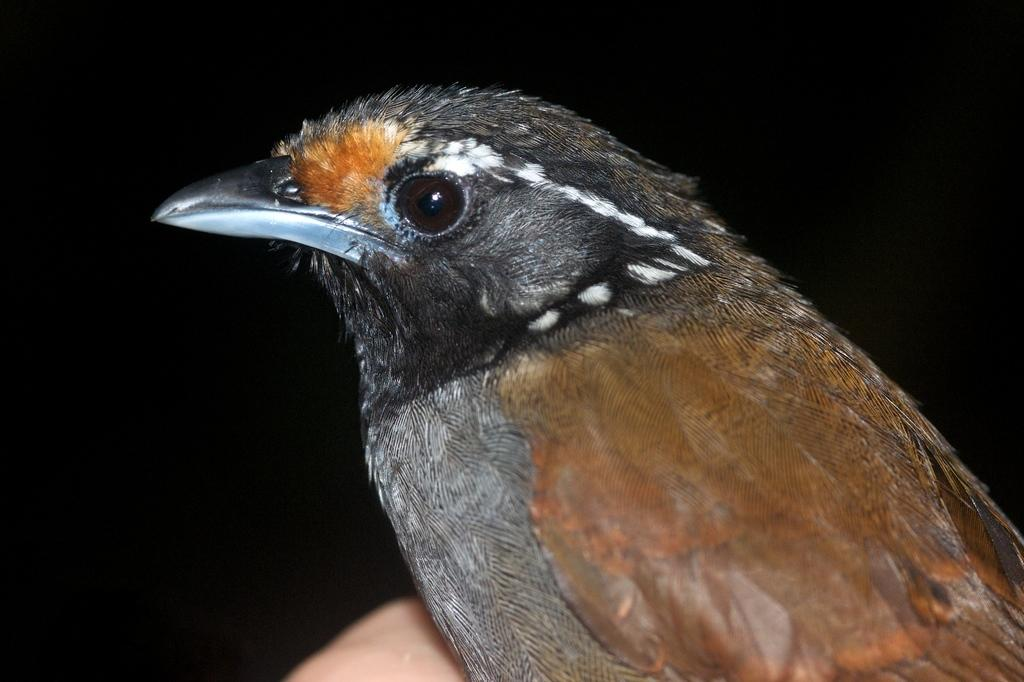What is the main subject of the image? There is a bird in the center of the image. What color is the background of the image? The background of the image is black. What type of haircut does the bird have in the image? There is no indication of a haircut in the image, as birds do not have hair. 